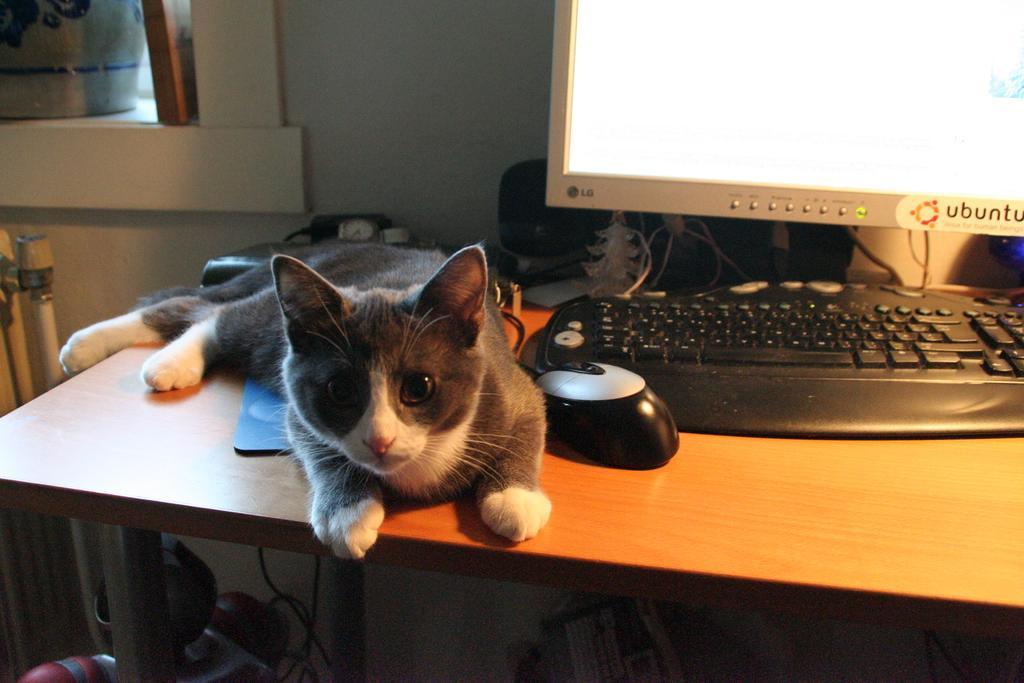How would you summarize this image in a sentence or two? In this image I can see there is a cat on the table. I can also see there is a monitor, a keyboard and a mouse. 